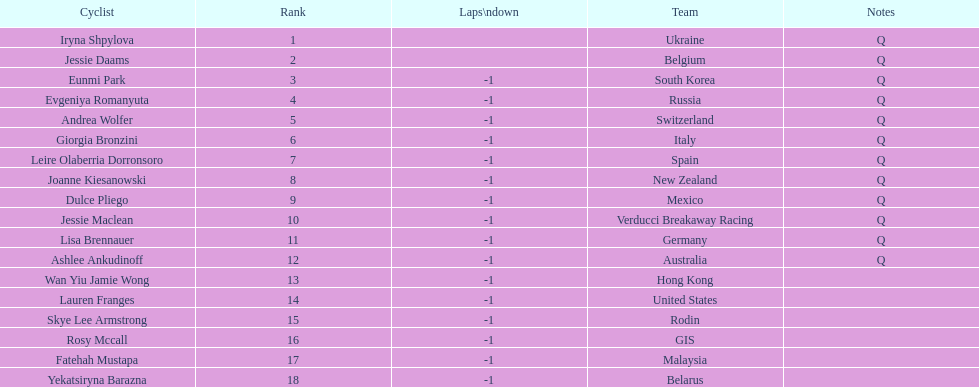What is the number rank of belgium? 2. 